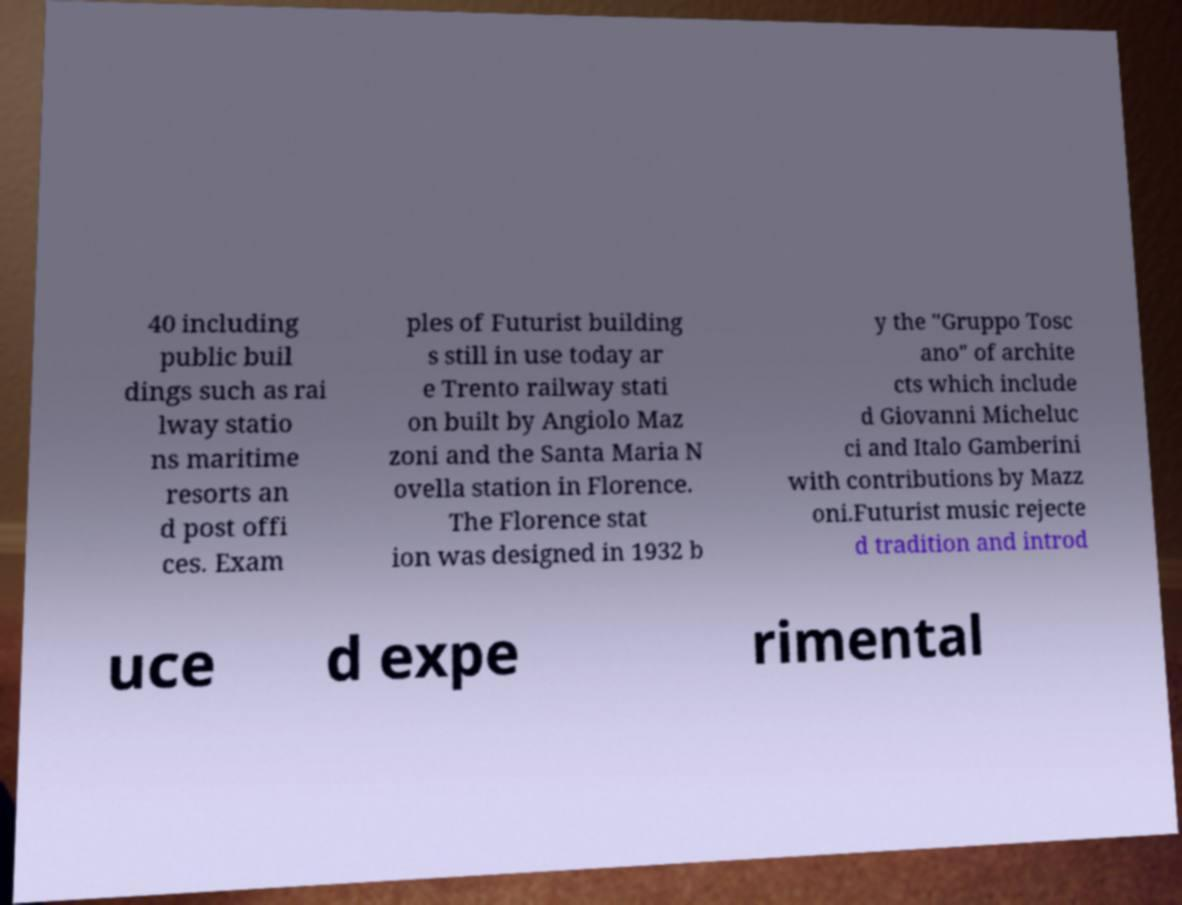Can you accurately transcribe the text from the provided image for me? 40 including public buil dings such as rai lway statio ns maritime resorts an d post offi ces. Exam ples of Futurist building s still in use today ar e Trento railway stati on built by Angiolo Maz zoni and the Santa Maria N ovella station in Florence. The Florence stat ion was designed in 1932 b y the "Gruppo Tosc ano" of archite cts which include d Giovanni Micheluc ci and Italo Gamberini with contributions by Mazz oni.Futurist music rejecte d tradition and introd uce d expe rimental 